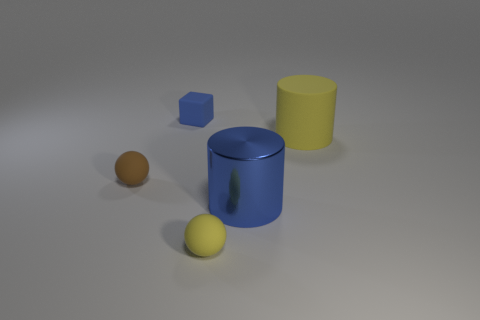Add 2 big yellow metallic cubes. How many objects exist? 7 Subtract all yellow cylinders. How many cylinders are left? 1 Subtract all cyan balls. Subtract all cyan cylinders. How many balls are left? 2 Subtract all green blocks. How many brown cylinders are left? 0 Subtract all big blue metallic things. Subtract all tiny green rubber spheres. How many objects are left? 4 Add 1 small rubber spheres. How many small rubber spheres are left? 3 Add 2 small cyan metallic cubes. How many small cyan metallic cubes exist? 2 Subtract 1 yellow spheres. How many objects are left? 4 Subtract all cubes. How many objects are left? 4 Subtract 1 cylinders. How many cylinders are left? 1 